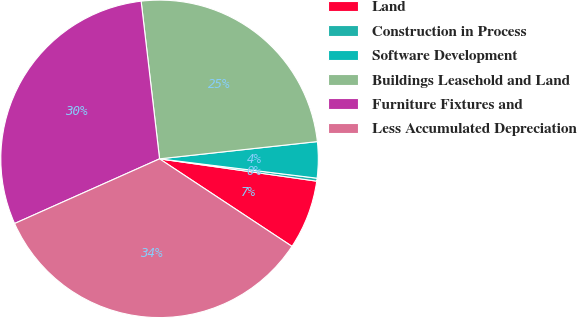<chart> <loc_0><loc_0><loc_500><loc_500><pie_chart><fcel>Land<fcel>Construction in Process<fcel>Software Development<fcel>Buildings Leasehold and Land<fcel>Furniture Fixtures and<fcel>Less Accumulated Depreciation<nl><fcel>7.05%<fcel>0.3%<fcel>3.68%<fcel>25.12%<fcel>29.83%<fcel>34.03%<nl></chart> 